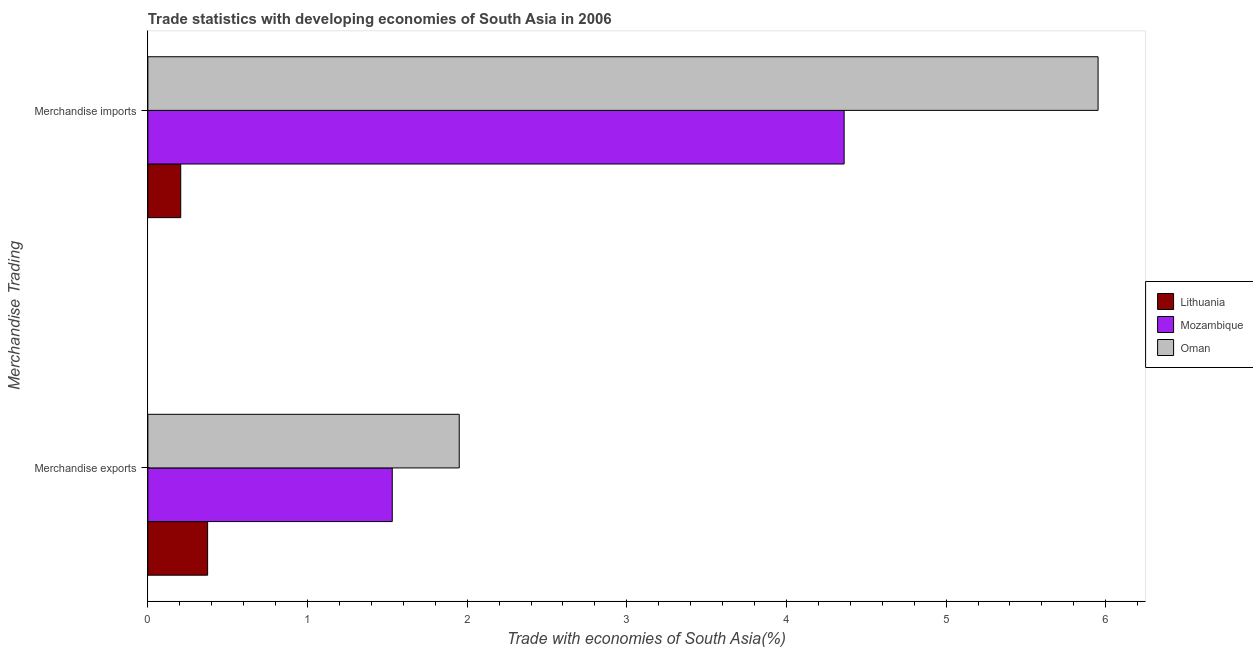How many different coloured bars are there?
Provide a succinct answer. 3. What is the merchandise exports in Oman?
Your answer should be compact. 1.95. Across all countries, what is the maximum merchandise exports?
Provide a succinct answer. 1.95. Across all countries, what is the minimum merchandise imports?
Offer a terse response. 0.21. In which country was the merchandise imports maximum?
Make the answer very short. Oman. In which country was the merchandise imports minimum?
Your answer should be compact. Lithuania. What is the total merchandise imports in the graph?
Ensure brevity in your answer.  10.52. What is the difference between the merchandise imports in Mozambique and that in Oman?
Your answer should be very brief. -1.59. What is the difference between the merchandise exports in Oman and the merchandise imports in Mozambique?
Offer a terse response. -2.41. What is the average merchandise imports per country?
Your answer should be compact. 3.51. What is the difference between the merchandise imports and merchandise exports in Oman?
Ensure brevity in your answer.  4. In how many countries, is the merchandise exports greater than 2.2 %?
Your answer should be compact. 0. What is the ratio of the merchandise exports in Oman to that in Mozambique?
Your response must be concise. 1.27. In how many countries, is the merchandise imports greater than the average merchandise imports taken over all countries?
Your response must be concise. 2. What does the 3rd bar from the top in Merchandise imports represents?
Your answer should be very brief. Lithuania. What does the 1st bar from the bottom in Merchandise imports represents?
Provide a short and direct response. Lithuania. How many countries are there in the graph?
Your answer should be very brief. 3. What is the difference between two consecutive major ticks on the X-axis?
Give a very brief answer. 1. Does the graph contain grids?
Give a very brief answer. No. Where does the legend appear in the graph?
Give a very brief answer. Center right. How many legend labels are there?
Your answer should be very brief. 3. How are the legend labels stacked?
Your answer should be compact. Vertical. What is the title of the graph?
Give a very brief answer. Trade statistics with developing economies of South Asia in 2006. Does "Nicaragua" appear as one of the legend labels in the graph?
Keep it short and to the point. No. What is the label or title of the X-axis?
Ensure brevity in your answer.  Trade with economies of South Asia(%). What is the label or title of the Y-axis?
Your response must be concise. Merchandise Trading. What is the Trade with economies of South Asia(%) in Lithuania in Merchandise exports?
Make the answer very short. 0.37. What is the Trade with economies of South Asia(%) of Mozambique in Merchandise exports?
Provide a succinct answer. 1.53. What is the Trade with economies of South Asia(%) of Oman in Merchandise exports?
Provide a succinct answer. 1.95. What is the Trade with economies of South Asia(%) in Lithuania in Merchandise imports?
Make the answer very short. 0.21. What is the Trade with economies of South Asia(%) in Mozambique in Merchandise imports?
Offer a very short reply. 4.36. What is the Trade with economies of South Asia(%) in Oman in Merchandise imports?
Keep it short and to the point. 5.95. Across all Merchandise Trading, what is the maximum Trade with economies of South Asia(%) in Lithuania?
Your answer should be very brief. 0.37. Across all Merchandise Trading, what is the maximum Trade with economies of South Asia(%) of Mozambique?
Your answer should be compact. 4.36. Across all Merchandise Trading, what is the maximum Trade with economies of South Asia(%) of Oman?
Give a very brief answer. 5.95. Across all Merchandise Trading, what is the minimum Trade with economies of South Asia(%) in Lithuania?
Your answer should be very brief. 0.21. Across all Merchandise Trading, what is the minimum Trade with economies of South Asia(%) of Mozambique?
Ensure brevity in your answer.  1.53. Across all Merchandise Trading, what is the minimum Trade with economies of South Asia(%) of Oman?
Provide a short and direct response. 1.95. What is the total Trade with economies of South Asia(%) of Lithuania in the graph?
Your answer should be very brief. 0.58. What is the total Trade with economies of South Asia(%) in Mozambique in the graph?
Your answer should be compact. 5.89. What is the total Trade with economies of South Asia(%) of Oman in the graph?
Make the answer very short. 7.9. What is the difference between the Trade with economies of South Asia(%) of Lithuania in Merchandise exports and that in Merchandise imports?
Offer a very short reply. 0.17. What is the difference between the Trade with economies of South Asia(%) in Mozambique in Merchandise exports and that in Merchandise imports?
Your answer should be very brief. -2.83. What is the difference between the Trade with economies of South Asia(%) of Oman in Merchandise exports and that in Merchandise imports?
Offer a terse response. -4. What is the difference between the Trade with economies of South Asia(%) in Lithuania in Merchandise exports and the Trade with economies of South Asia(%) in Mozambique in Merchandise imports?
Keep it short and to the point. -3.99. What is the difference between the Trade with economies of South Asia(%) in Lithuania in Merchandise exports and the Trade with economies of South Asia(%) in Oman in Merchandise imports?
Your response must be concise. -5.58. What is the difference between the Trade with economies of South Asia(%) in Mozambique in Merchandise exports and the Trade with economies of South Asia(%) in Oman in Merchandise imports?
Your answer should be very brief. -4.42. What is the average Trade with economies of South Asia(%) in Lithuania per Merchandise Trading?
Ensure brevity in your answer.  0.29. What is the average Trade with economies of South Asia(%) in Mozambique per Merchandise Trading?
Your answer should be compact. 2.95. What is the average Trade with economies of South Asia(%) of Oman per Merchandise Trading?
Make the answer very short. 3.95. What is the difference between the Trade with economies of South Asia(%) in Lithuania and Trade with economies of South Asia(%) in Mozambique in Merchandise exports?
Provide a succinct answer. -1.16. What is the difference between the Trade with economies of South Asia(%) of Lithuania and Trade with economies of South Asia(%) of Oman in Merchandise exports?
Provide a short and direct response. -1.58. What is the difference between the Trade with economies of South Asia(%) of Mozambique and Trade with economies of South Asia(%) of Oman in Merchandise exports?
Your response must be concise. -0.42. What is the difference between the Trade with economies of South Asia(%) of Lithuania and Trade with economies of South Asia(%) of Mozambique in Merchandise imports?
Give a very brief answer. -4.16. What is the difference between the Trade with economies of South Asia(%) of Lithuania and Trade with economies of South Asia(%) of Oman in Merchandise imports?
Your response must be concise. -5.75. What is the difference between the Trade with economies of South Asia(%) of Mozambique and Trade with economies of South Asia(%) of Oman in Merchandise imports?
Ensure brevity in your answer.  -1.59. What is the ratio of the Trade with economies of South Asia(%) in Lithuania in Merchandise exports to that in Merchandise imports?
Your response must be concise. 1.82. What is the ratio of the Trade with economies of South Asia(%) in Mozambique in Merchandise exports to that in Merchandise imports?
Your answer should be very brief. 0.35. What is the ratio of the Trade with economies of South Asia(%) of Oman in Merchandise exports to that in Merchandise imports?
Provide a succinct answer. 0.33. What is the difference between the highest and the second highest Trade with economies of South Asia(%) of Lithuania?
Provide a succinct answer. 0.17. What is the difference between the highest and the second highest Trade with economies of South Asia(%) in Mozambique?
Provide a succinct answer. 2.83. What is the difference between the highest and the second highest Trade with economies of South Asia(%) of Oman?
Ensure brevity in your answer.  4. What is the difference between the highest and the lowest Trade with economies of South Asia(%) in Lithuania?
Offer a very short reply. 0.17. What is the difference between the highest and the lowest Trade with economies of South Asia(%) of Mozambique?
Offer a terse response. 2.83. What is the difference between the highest and the lowest Trade with economies of South Asia(%) in Oman?
Your response must be concise. 4. 